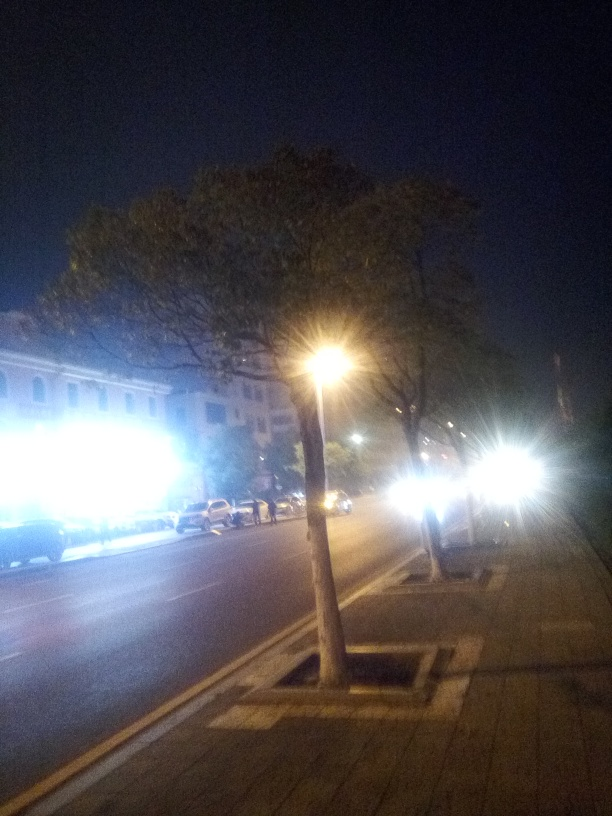Can you tell me about the weather conditions in this image? Given the absence of shadows and the overall haziness, it's likely that the weather is overcast or foggy. However, the specifics cannot be determined with certainty due to the image's quality issues. Does it look like it's about to rain, or has it just rained? There are no visible wet surfaces or raindrops that would indicate recent rainfall, and without additional context or a clearer image, predicting imminent rain is challenging. 